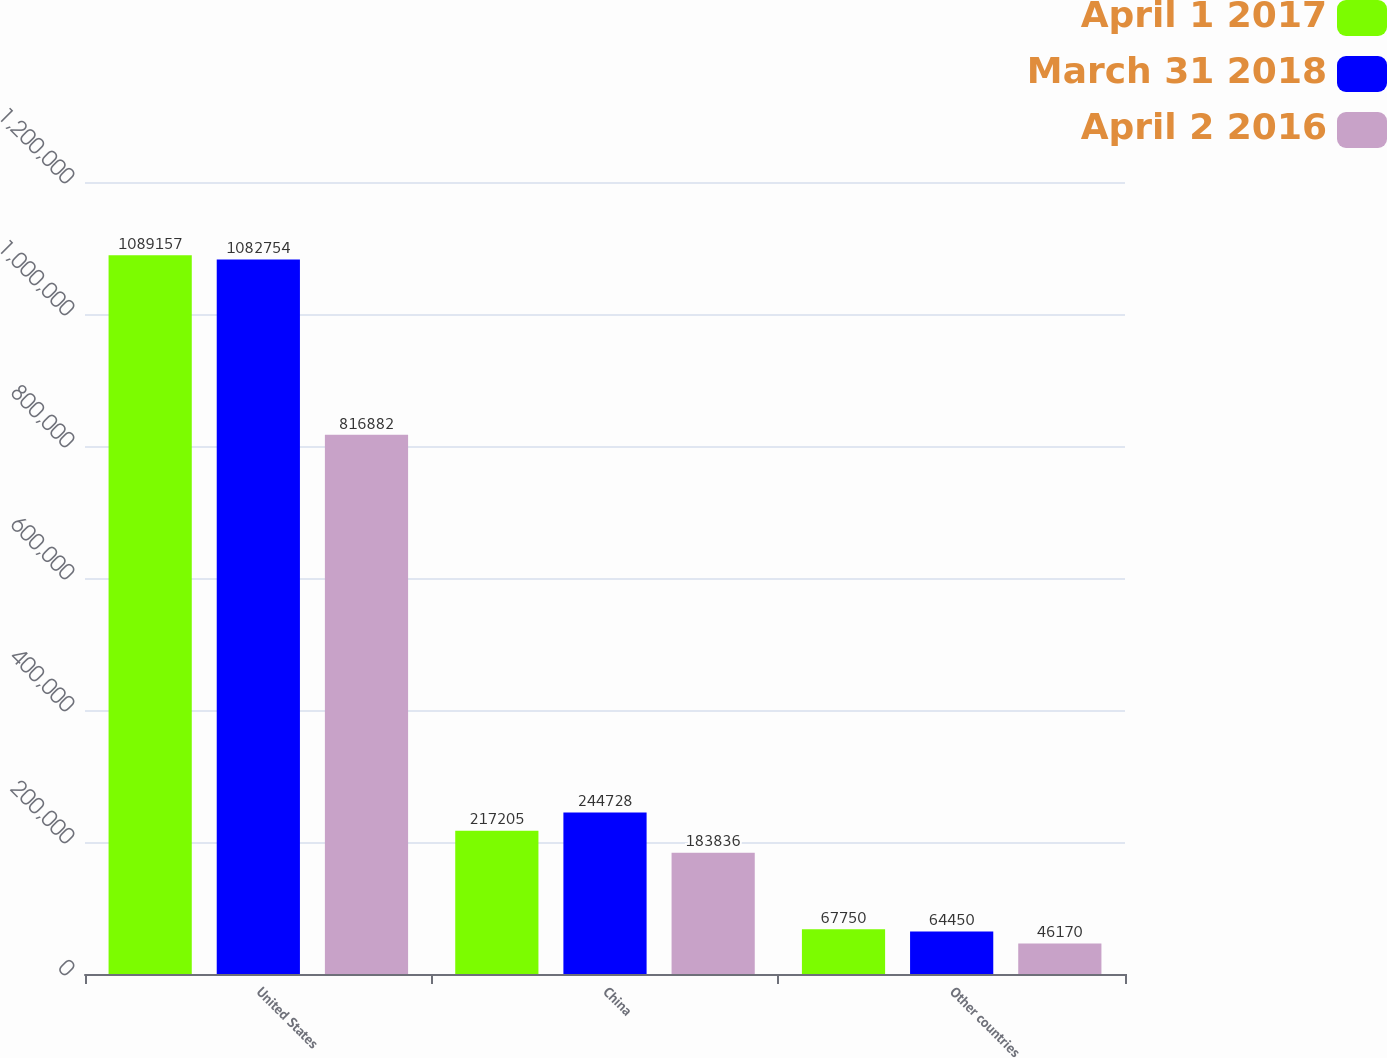<chart> <loc_0><loc_0><loc_500><loc_500><stacked_bar_chart><ecel><fcel>United States<fcel>China<fcel>Other countries<nl><fcel>April 1 2017<fcel>1.08916e+06<fcel>217205<fcel>67750<nl><fcel>March 31 2018<fcel>1.08275e+06<fcel>244728<fcel>64450<nl><fcel>April 2 2016<fcel>816882<fcel>183836<fcel>46170<nl></chart> 